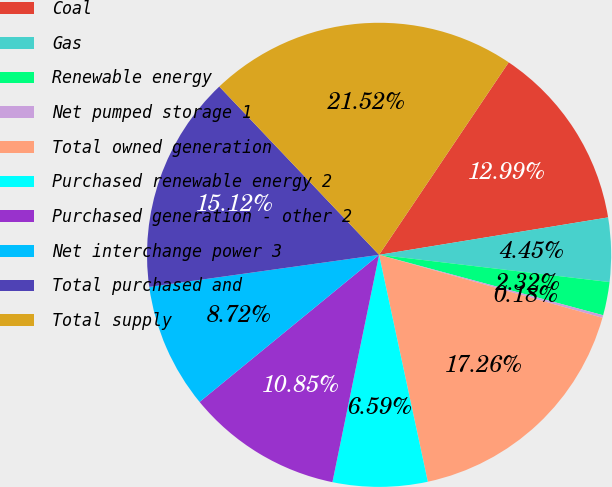Convert chart to OTSL. <chart><loc_0><loc_0><loc_500><loc_500><pie_chart><fcel>Coal<fcel>Gas<fcel>Renewable energy<fcel>Net pumped storage 1<fcel>Total owned generation<fcel>Purchased renewable energy 2<fcel>Purchased generation - other 2<fcel>Net interchange power 3<fcel>Total purchased and<fcel>Total supply<nl><fcel>12.99%<fcel>4.45%<fcel>2.32%<fcel>0.18%<fcel>17.26%<fcel>6.59%<fcel>10.85%<fcel>8.72%<fcel>15.12%<fcel>21.52%<nl></chart> 